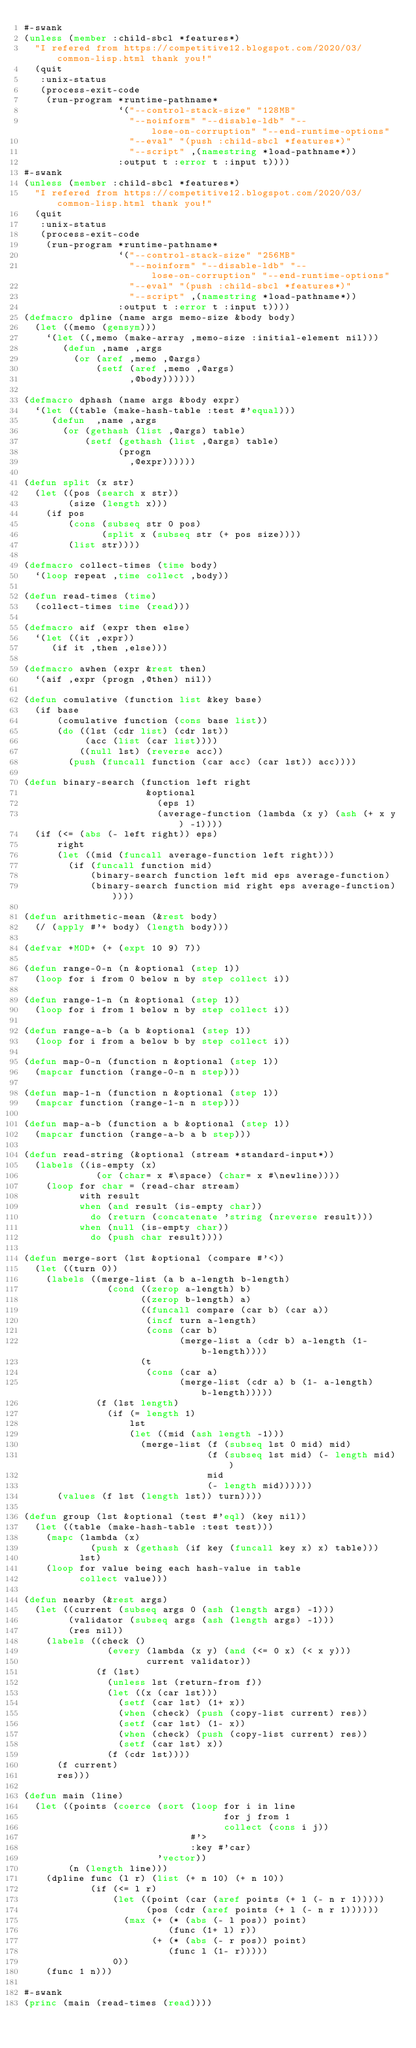<code> <loc_0><loc_0><loc_500><loc_500><_Lisp_>#-swank
(unless (member :child-sbcl *features*)
  "I refered from https://competitive12.blogspot.com/2020/03/common-lisp.html thank you!"
  (quit
   :unix-status
   (process-exit-code
    (run-program *runtime-pathname*
                 `("--control-stack-size" "128MB"
                   "--noinform" "--disable-ldb" "--lose-on-corruption" "--end-runtime-options"
                   "--eval" "(push :child-sbcl *features*)"
                   "--script" ,(namestring *load-pathname*))
                 :output t :error t :input t))))
#-swank
(unless (member :child-sbcl *features*)
  "I refered from https://competitive12.blogspot.com/2020/03/common-lisp.html thank you!"
  (quit
   :unix-status
   (process-exit-code
    (run-program *runtime-pathname*
                 `("--control-stack-size" "256MB"
                   "--noinform" "--disable-ldb" "--lose-on-corruption" "--end-runtime-options"
                   "--eval" "(push :child-sbcl *features*)"
                   "--script" ,(namestring *load-pathname*))
                 :output t :error t :input t))))
(defmacro dpline (name args memo-size &body body)
  (let ((memo (gensym)))
    `(let ((,memo (make-array ,memo-size :initial-element nil)))
       (defun ,name ,args
         (or (aref ,memo ,@args)
             (setf (aref ,memo ,@args)
                   ,@body))))))

(defmacro dphash (name args &body expr)
  `(let ((table (make-hash-table :test #'equal)))
     (defun  ,name ,args 
       (or (gethash (list ,@args) table)
           (setf (gethash (list ,@args) table)
                 (progn 
                   ,@expr))))))

(defun split (x str)
  (let ((pos (search x str))
        (size (length x)))
    (if pos
        (cons (subseq str 0 pos)
              (split x (subseq str (+ pos size))))
        (list str))))

(defmacro collect-times (time body)
  `(loop repeat ,time collect ,body))

(defun read-times (time)
  (collect-times time (read)))

(defmacro aif (expr then else)
  `(let ((it ,expr))
     (if it ,then ,else)))

(defmacro awhen (expr &rest then)
  `(aif ,expr (progn ,@then) nil))

(defun comulative (function list &key base)
  (if base
      (comulative function (cons base list))
      (do ((lst (cdr list) (cdr lst))
           (acc (list (car list))))
          ((null lst) (reverse acc))
        (push (funcall function (car acc) (car lst)) acc))))

(defun binary-search (function left right
                      &optional
                        (eps 1)
                        (average-function (lambda (x y) (ash (+ x y) -1))))
  (if (<= (abs (- left right)) eps)
      right
      (let ((mid (funcall average-function left right)))
        (if (funcall function mid)
            (binary-search function left mid eps average-function)
            (binary-search function mid right eps average-function)))))

(defun arithmetic-mean (&rest body)
  (/ (apply #'+ body) (length body)))

(defvar +MOD+ (+ (expt 10 9) 7))

(defun range-0-n (n &optional (step 1))
  (loop for i from 0 below n by step collect i))

(defun range-1-n (n &optional (step 1))
  (loop for i from 1 below n by step collect i))

(defun range-a-b (a b &optional (step 1))
  (loop for i from a below b by step collect i))

(defun map-0-n (function n &optional (step 1))
  (mapcar function (range-0-n n step)))

(defun map-1-n (function n &optional (step 1))
  (mapcar function (range-1-n n step)))

(defun map-a-b (function a b &optional (step 1))
  (mapcar function (range-a-b a b step)))

(defun read-string (&optional (stream *standard-input*))
  (labels ((is-empty (x)
             (or (char= x #\space) (char= x #\newline))))
    (loop for char = (read-char stream)
          with result
          when (and result (is-empty char))
            do (return (concatenate 'string (nreverse result)))
          when (null (is-empty char))
            do (push char result))))

(defun merge-sort (lst &optional (compare #'<))
  (let ((turn 0))
    (labels ((merge-list (a b a-length b-length)
               (cond ((zerop a-length) b)
                     ((zerop b-length) a)
                     ((funcall compare (car b) (car a))
                      (incf turn a-length)
                      (cons (car b)
                            (merge-list a (cdr b) a-length (1- b-length))))
                     (t
                      (cons (car a)
                            (merge-list (cdr a) b (1- a-length) b-length)))))
             (f (lst length)
               (if (= length 1)
                   lst
                   (let ((mid (ash length -1)))
                     (merge-list (f (subseq lst 0 mid) mid)
                                 (f (subseq lst mid) (- length mid))
                                 mid
                                 (- length mid))))))
      (values (f lst (length lst)) turn))))

(defun group (lst &optional (test #'eql) (key nil))
  (let ((table (make-hash-table :test test)))
    (mapc (lambda (x)
            (push x (gethash (if key (funcall key x) x) table)))
          lst)
    (loop for value being each hash-value in table
          collect value)))

(defun nearby (&rest args)
  (let ((current (subseq args 0 (ash (length args) -1)))
        (validator (subseq args (ash (length args) -1)))
        (res nil))
    (labels ((check ()
               (every (lambda (x y) (and (<= 0 x) (< x y)))
                      current validator))
             (f (lst)
               (unless lst (return-from f))
               (let ((x (car lst)))
                 (setf (car lst) (1+ x))
                 (when (check) (push (copy-list current) res))
                 (setf (car lst) (1- x))
                 (when (check) (push (copy-list current) res))
                 (setf (car lst) x))
               (f (cdr lst))))
      (f current)
      res)))

(defun main (line)
  (let ((points (coerce (sort (loop for i in line
                                    for j from 1
                                    collect (cons i j))
                              #'>
                              :key #'car)
                        'vector))
        (n (length line)))
    (dpline func (l r) (list (+ n 10) (+ n 10))
            (if (<= l r)
                (let ((point (car (aref points (+ l (- n r 1)))))
                      (pos (cdr (aref points (+ l (- n r 1))))))
                  (max (+ (* (abs (- l pos)) point)
                          (func (1+ l) r))
                       (+ (* (abs (- r pos)) point)
                          (func l (1- r)))))
                0))
    (func 1 n)))

#-swank
(princ (main (read-times (read))))
</code> 